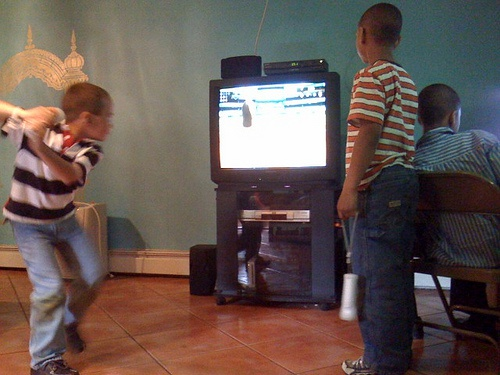Describe the objects in this image and their specific colors. I can see people in gray, black, and maroon tones, people in gray, maroon, black, and darkgray tones, tv in gray, white, and black tones, people in gray, black, and blue tones, and chair in gray, black, maroon, and darkgray tones in this image. 